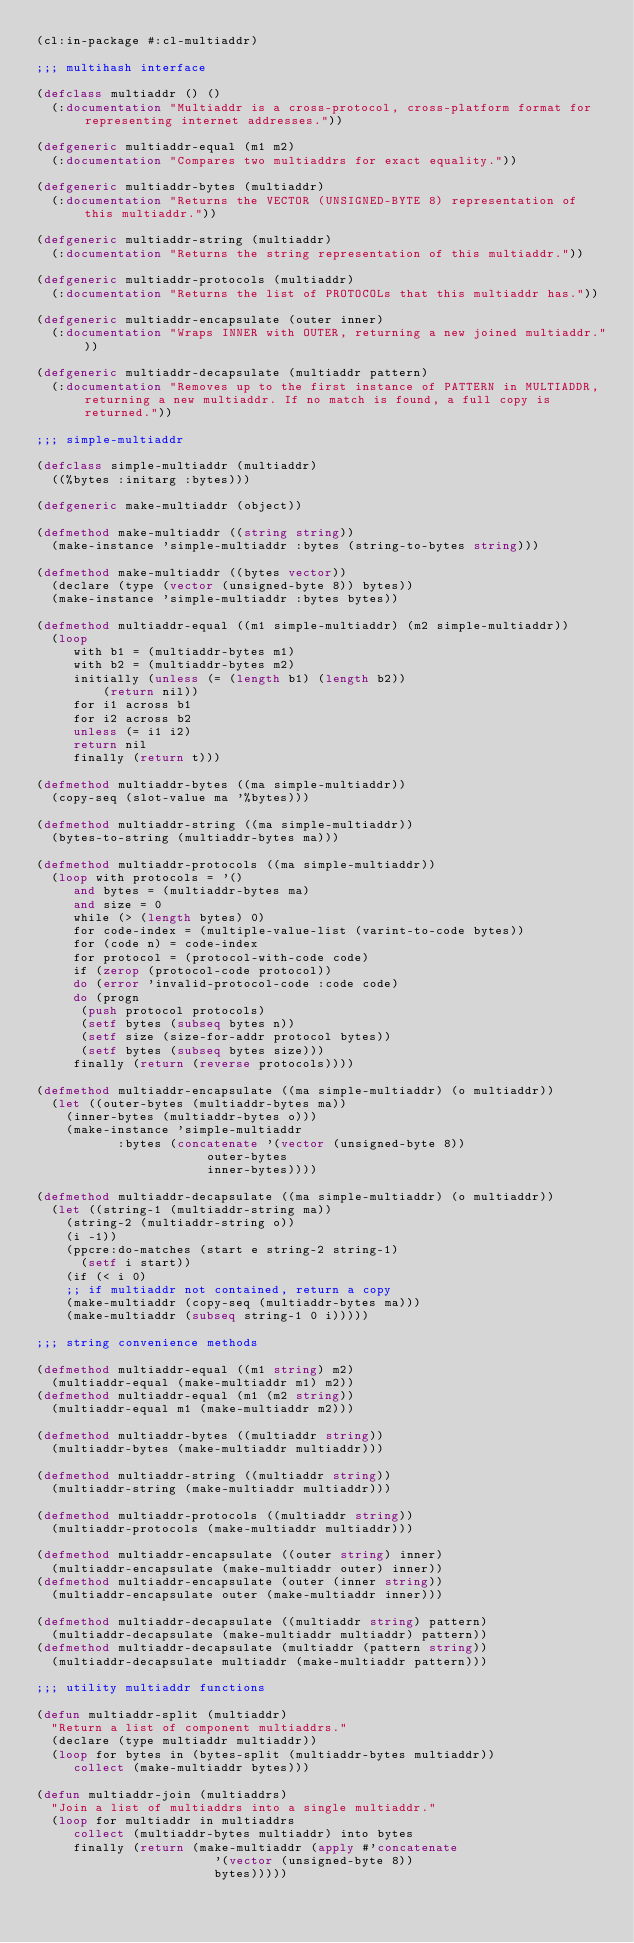Convert code to text. <code><loc_0><loc_0><loc_500><loc_500><_Lisp_>(cl:in-package #:cl-multiaddr)

;;; multihash interface

(defclass multiaddr () ()
  (:documentation "Multiaddr is a cross-protocol, cross-platform format for representing internet addresses."))

(defgeneric multiaddr-equal (m1 m2)
  (:documentation "Compares two multiaddrs for exact equality."))

(defgeneric multiaddr-bytes (multiaddr)
  (:documentation "Returns the VECTOR (UNSIGNED-BYTE 8) representation of this multiaddr."))

(defgeneric multiaddr-string (multiaddr)
  (:documentation "Returns the string representation of this multiaddr."))

(defgeneric multiaddr-protocols (multiaddr)
  (:documentation "Returns the list of PROTOCOLs that this multiaddr has."))

(defgeneric multiaddr-encapsulate (outer inner)
  (:documentation "Wraps INNER with OUTER, returning a new joined multiaddr."))

(defgeneric multiaddr-decapsulate (multiaddr pattern)
  (:documentation "Removes up to the first instance of PATTERN in MULTIADDR, returning a new multiaddr. If no match is found, a full copy is returned."))

;;; simple-multiaddr

(defclass simple-multiaddr (multiaddr)
  ((%bytes :initarg :bytes)))

(defgeneric make-multiaddr (object))

(defmethod make-multiaddr ((string string))
  (make-instance 'simple-multiaddr :bytes (string-to-bytes string)))

(defmethod make-multiaddr ((bytes vector))
  (declare (type (vector (unsigned-byte 8)) bytes))
  (make-instance 'simple-multiaddr :bytes bytes))

(defmethod multiaddr-equal ((m1 simple-multiaddr) (m2 simple-multiaddr))
  (loop
     with b1 = (multiaddr-bytes m1)
     with b2 = (multiaddr-bytes m2)
     initially (unless (= (length b1) (length b2))
		 (return nil))
     for i1 across b1
     for i2 across b2
     unless (= i1 i2)
     return nil
     finally (return t)))

(defmethod multiaddr-bytes ((ma simple-multiaddr))
  (copy-seq (slot-value ma '%bytes)))

(defmethod multiaddr-string ((ma simple-multiaddr))
  (bytes-to-string (multiaddr-bytes ma)))

(defmethod multiaddr-protocols ((ma simple-multiaddr))
  (loop with protocols = '()
     and bytes = (multiaddr-bytes ma)
     and size = 0
     while (> (length bytes) 0)
     for code-index = (multiple-value-list (varint-to-code bytes))
     for (code n) = code-index
     for protocol = (protocol-with-code code)
     if (zerop (protocol-code protocol))
     do (error 'invalid-protocol-code :code code)
     do (progn
	  (push protocol protocols)
	  (setf bytes (subseq bytes n))
	  (setf size (size-for-addr protocol bytes))
	  (setf bytes (subseq bytes size)))
     finally (return (reverse protocols))))

(defmethod multiaddr-encapsulate ((ma simple-multiaddr) (o multiaddr))
  (let ((outer-bytes (multiaddr-bytes ma))
	(inner-bytes (multiaddr-bytes o)))
    (make-instance 'simple-multiaddr
		   :bytes (concatenate '(vector (unsigned-byte 8))
				       outer-bytes
				       inner-bytes))))

(defmethod multiaddr-decapsulate ((ma simple-multiaddr) (o multiaddr))
  (let ((string-1 (multiaddr-string ma))
	(string-2 (multiaddr-string o))
	(i -1))
    (ppcre:do-matches (start e string-2 string-1)
      (setf i start))
    (if (< i 0)
	;; if multiaddr not contained, return a copy
	(make-multiaddr (copy-seq (multiaddr-bytes ma)))
	(make-multiaddr (subseq string-1 0 i)))))

;;; string convenience methods

(defmethod multiaddr-equal ((m1 string) m2)
  (multiaddr-equal (make-multiaddr m1) m2))
(defmethod multiaddr-equal (m1 (m2 string))
  (multiaddr-equal m1 (make-multiaddr m2)))

(defmethod multiaddr-bytes ((multiaddr string))
  (multiaddr-bytes (make-multiaddr multiaddr)))

(defmethod multiaddr-string ((multiaddr string))
  (multiaddr-string (make-multiaddr multiaddr)))

(defmethod multiaddr-protocols ((multiaddr string))
  (multiaddr-protocols (make-multiaddr multiaddr)))

(defmethod multiaddr-encapsulate ((outer string) inner)
  (multiaddr-encapsulate (make-multiaddr outer) inner))
(defmethod multiaddr-encapsulate (outer (inner string))
  (multiaddr-encapsulate outer (make-multiaddr inner)))

(defmethod multiaddr-decapsulate ((multiaddr string) pattern)
  (multiaddr-decapsulate (make-multiaddr multiaddr) pattern))
(defmethod multiaddr-decapsulate (multiaddr (pattern string))
  (multiaddr-decapsulate multiaddr (make-multiaddr pattern)))

;;; utility multiaddr functions

(defun multiaddr-split (multiaddr)
  "Return a list of component multiaddrs."
  (declare (type multiaddr multiaddr))
  (loop for bytes in (bytes-split (multiaddr-bytes multiaddr))
     collect (make-multiaddr bytes)))

(defun multiaddr-join (multiaddrs)
  "Join a list of multiaddrs into a single multiaddr."
  (loop for multiaddr in multiaddrs
     collect (multiaddr-bytes multiaddr) into bytes
     finally (return (make-multiaddr (apply #'concatenate
					    '(vector (unsigned-byte 8))
					    bytes)))))
</code> 